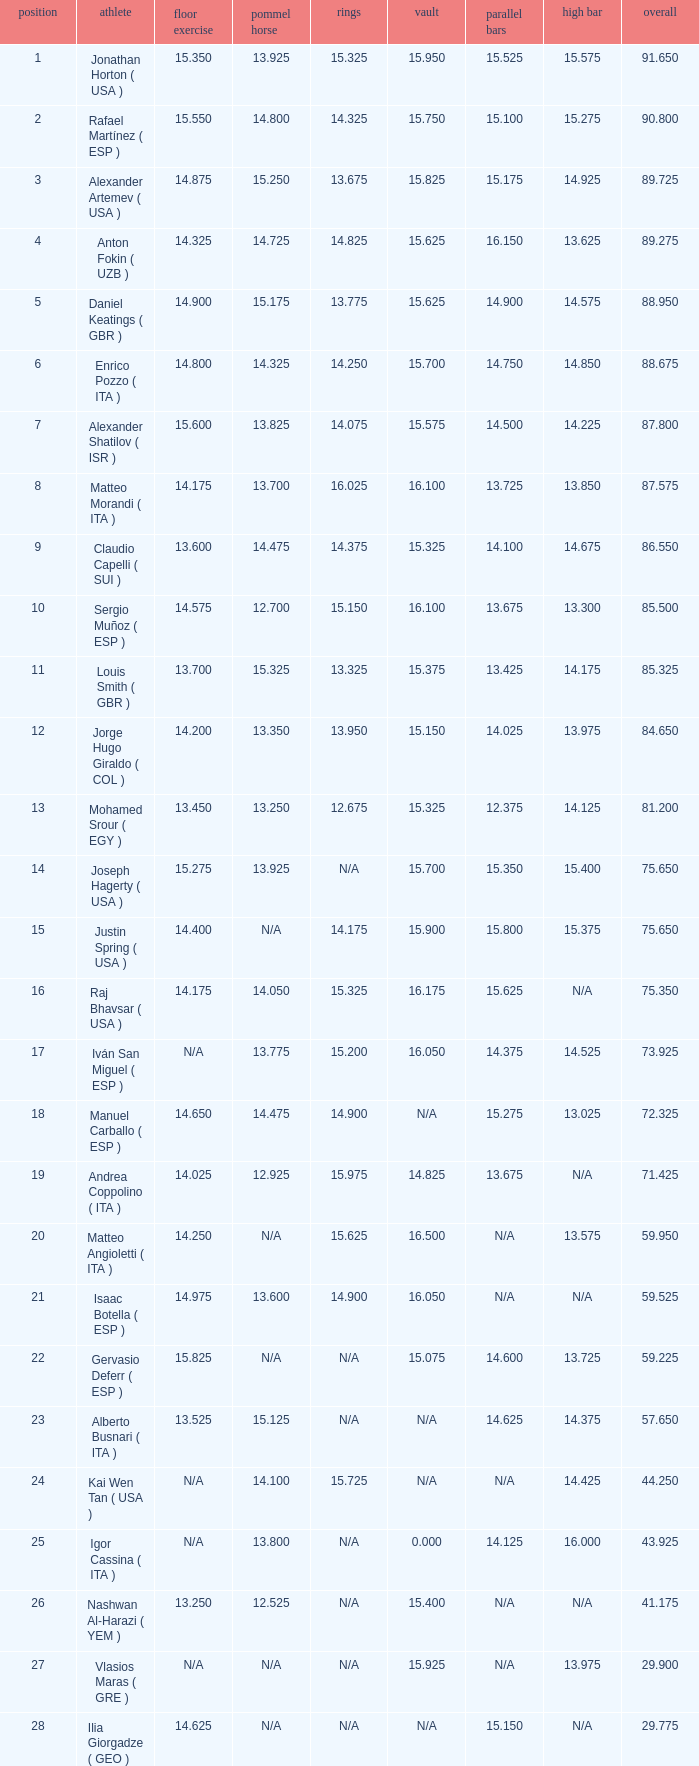If the parallel bars score is 1 Anton Fokin ( UZB ). 